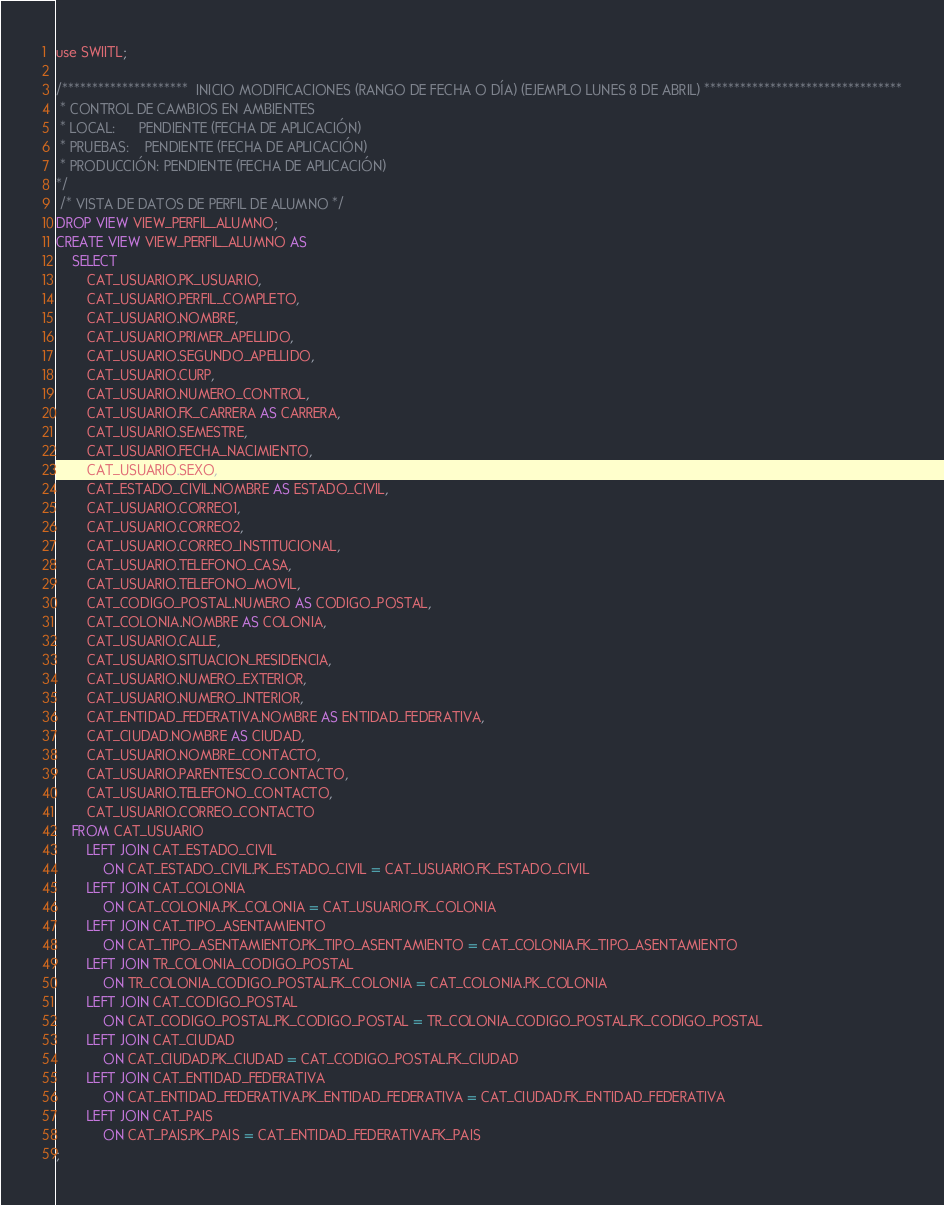Convert code to text. <code><loc_0><loc_0><loc_500><loc_500><_SQL_>use SWIITL;

/*********************  INICIO MODIFICACIONES (RANGO DE FECHA O DÍA) (EJEMPLO LUNES 8 DE ABRIL) *********************************
 * CONTROL DE CAMBIOS EN AMBIENTES
 * LOCAL:      PENDIENTE (FECHA DE APLICACIÓN)
 * PRUEBAS:    PENDIENTE (FECHA DE APLICACIÓN)
 * PRODUCCIÓN: PENDIENTE (FECHA DE APLICACIÓN)
*/
 /* VISTA DE DATOS DE PERFIL DE ALUMNO */
DROP VIEW VIEW_PERFIL_ALUMNO;
CREATE VIEW VIEW_PERFIL_ALUMNO AS
    SELECT
        CAT_USUARIO.PK_USUARIO,
        CAT_USUARIO.PERFIL_COMPLETO,
        CAT_USUARIO.NOMBRE,
        CAT_USUARIO.PRIMER_APELLIDO,
        CAT_USUARIO.SEGUNDO_APELLIDO,
        CAT_USUARIO.CURP,
        CAT_USUARIO.NUMERO_CONTROL,
        CAT_USUARIO.FK_CARRERA AS CARRERA,
        CAT_USUARIO.SEMESTRE,
        CAT_USUARIO.FECHA_NACIMIENTO,
        CAT_USUARIO.SEXO,
        CAT_ESTADO_CIVIL.NOMBRE AS ESTADO_CIVIL,
        CAT_USUARIO.CORREO1,
        CAT_USUARIO.CORREO2,
        CAT_USUARIO.CORREO_INSTITUCIONAL,
        CAT_USUARIO.TELEFONO_CASA,
        CAT_USUARIO.TELEFONO_MOVIL,
        CAT_CODIGO_POSTAL.NUMERO AS CODIGO_POSTAL,
        CAT_COLONIA.NOMBRE AS COLONIA,
        CAT_USUARIO.CALLE,
        CAT_USUARIO.SITUACION_RESIDENCIA,
        CAT_USUARIO.NUMERO_EXTERIOR,
        CAT_USUARIO.NUMERO_INTERIOR,
        CAT_ENTIDAD_FEDERATIVA.NOMBRE AS ENTIDAD_FEDERATIVA,
        CAT_CIUDAD.NOMBRE AS CIUDAD,
        CAT_USUARIO.NOMBRE_CONTACTO,
        CAT_USUARIO.PARENTESCO_CONTACTO,
        CAT_USUARIO.TELEFONO_CONTACTO,
        CAT_USUARIO.CORREO_CONTACTO
    FROM CAT_USUARIO
        LEFT JOIN CAT_ESTADO_CIVIL
            ON CAT_ESTADO_CIVIL.PK_ESTADO_CIVIL = CAT_USUARIO.FK_ESTADO_CIVIL
        LEFT JOIN CAT_COLONIA
            ON CAT_COLONIA.PK_COLONIA = CAT_USUARIO.FK_COLONIA
        LEFT JOIN CAT_TIPO_ASENTAMIENTO
            ON CAT_TIPO_ASENTAMIENTO.PK_TIPO_ASENTAMIENTO = CAT_COLONIA.FK_TIPO_ASENTAMIENTO
        LEFT JOIN TR_COLONIA_CODIGO_POSTAL
            ON TR_COLONIA_CODIGO_POSTAL.FK_COLONIA = CAT_COLONIA.PK_COLONIA
        LEFT JOIN CAT_CODIGO_POSTAL
            ON CAT_CODIGO_POSTAL.PK_CODIGO_POSTAL = TR_COLONIA_CODIGO_POSTAL.FK_CODIGO_POSTAL
        LEFT JOIN CAT_CIUDAD
            ON CAT_CIUDAD.PK_CIUDAD = CAT_CODIGO_POSTAL.FK_CIUDAD
        LEFT JOIN CAT_ENTIDAD_FEDERATIVA
            ON CAT_ENTIDAD_FEDERATIVA.PK_ENTIDAD_FEDERATIVA = CAT_CIUDAD.FK_ENTIDAD_FEDERATIVA
        LEFT JOIN CAT_PAIS
            ON CAT_PAIS.PK_PAIS = CAT_ENTIDAD_FEDERATIVA.FK_PAIS
;
</code> 